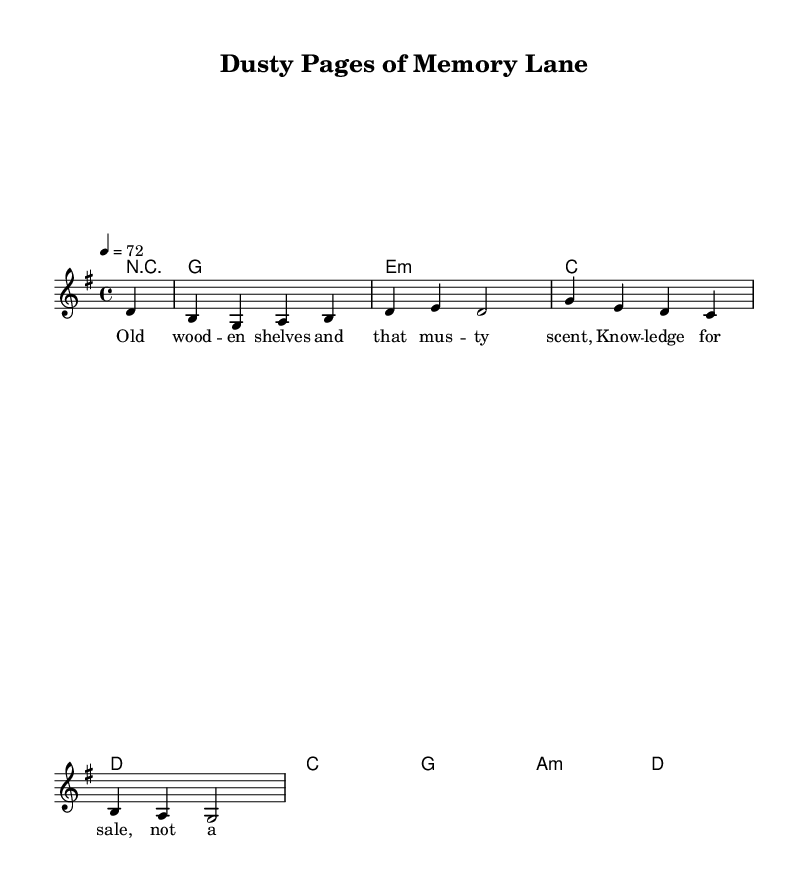What is the key signature of this music? The key signature is G major, which has one sharp (F#).
Answer: G major What is the time signature of the piece? The time signature is indicated as 4/4, meaning there are four beats in each measure.
Answer: 4/4 What is the tempo marking for this score? The tempo marking indicates a pace of 72 beats per minute, which is written as a quarter note equals 72.
Answer: 72 How many distinct chords are used in the harmony section? The harmony section lists seven different chords used throughout the score. Each chord corresponds to the measures defined in the chord mode.
Answer: Seven What is the lyrical theme of the song? The lyrics reflect on nostalgia and memories associated with old bookstores, emphasizing the warmth and comfort of knowledge within those spaces.
Answer: Nostalgia How does the melody relate to the lyrics in terms of emotional expression? The melody has a reflective and gentle rise and fall that complements the wistful tone of the lyrics about memories of bookstores, creating an emotional connection.
Answer: Reflective What is the structure of the piece (e.g. verse, chorus)? The piece is structured as a verse, with traditional country rock elements, focusing on storytelling through lyrics.
Answer: Verse 